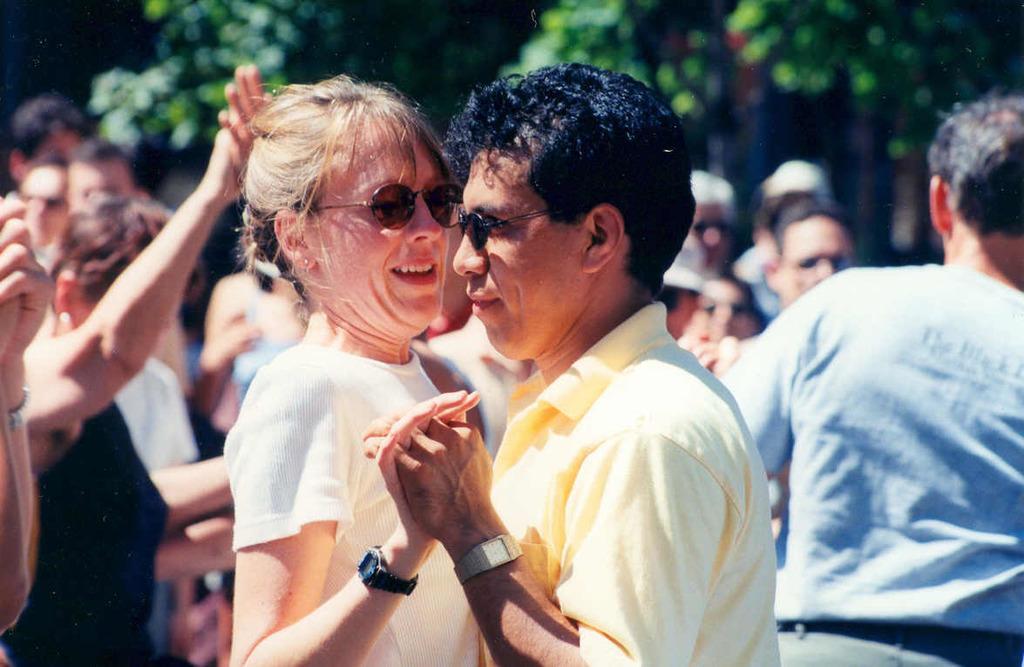In one or two sentences, can you explain what this image depicts? In this picture we can see a group of people, some people are wearing spectacles, watches and in the background we can see trees it is blurry. 